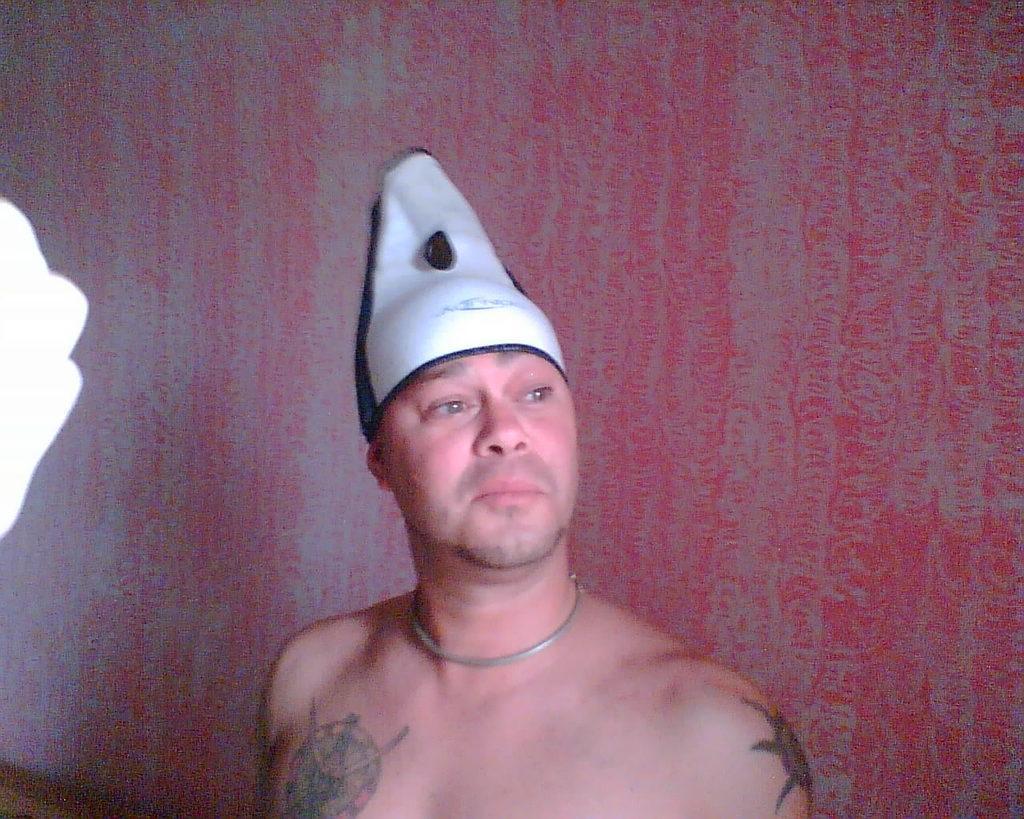Please provide a concise description of this image. In this image I can see a man and I can see he is wearing white colour cap. I can also see few tattoos on his body and in background I can see red colour. 